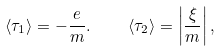Convert formula to latex. <formula><loc_0><loc_0><loc_500><loc_500>\langle \tau _ { 1 } \rangle = - \frac { e } { m } . \quad \ \langle \tau _ { 2 } \rangle = \left | \frac { \xi } { m } \right | ,</formula> 